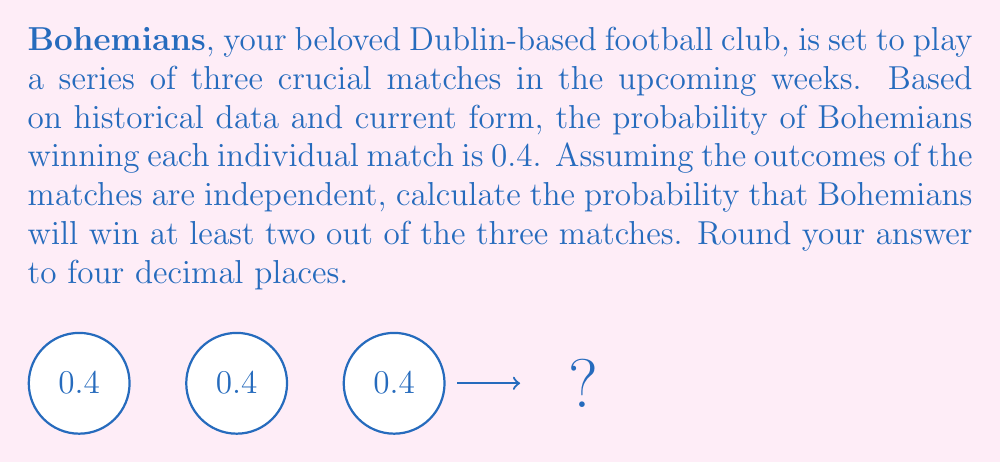Teach me how to tackle this problem. Let's approach this step-by-step:

1) First, we need to identify the possible favorable outcomes:
   - Bohemians wins all three matches
   - Bohemians wins exactly two out of three matches

2) Let's calculate the probability of each scenario:

   a) Probability of winning all three matches:
      $$P(\text{all wins}) = 0.4 \times 0.4 \times 0.4 = 0.4^3 = 0.064$$

   b) Probability of winning exactly two out of three matches:
      There are three ways this can happen: WWL, WLW, LWW
      Each of these has a probability of:
      $$0.4 \times 0.4 \times 0.6 = 0.096$$
      
      Since there are three such combinations:
      $$P(\text{two wins}) = 3 \times 0.096 = 0.288$$

3) The probability of at least two wins is the sum of the probabilities of exactly two wins and all three wins:

   $$P(\text{at least two wins}) = P(\text{two wins}) + P(\text{all wins})$$
   $$P(\text{at least two wins}) = 0.288 + 0.064 = 0.352$$

4) Rounding to four decimal places:
   $$0.352 \approx 0.3520$$

Therefore, the probability of Bohemians winning at least two out of the three matches is 0.3520 or 35.20%.
Answer: $0.3520$ 